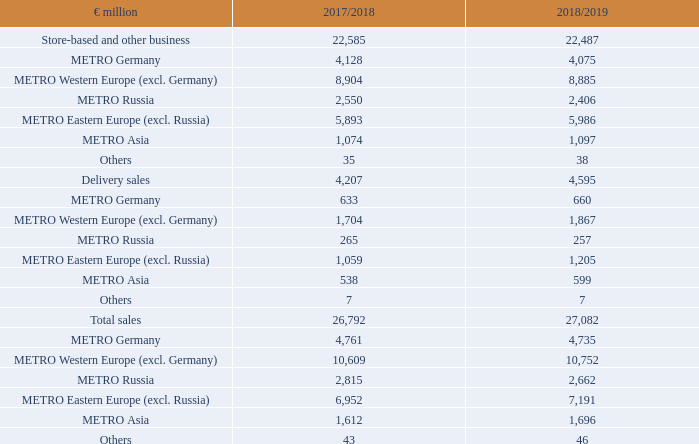1. Sales revenues
Commencing with financial year 2018/19, METRO has been applying IFRS 15 (Revenue from Contracts with Customers). The sales revenues reported for the current financial year relate exclusively to revenues from contracts with customers.
Sales revenues are allocated to the following categories:
When has METRO started applying IFRS 15? Commencing with financial year 2018/19. What do to the sales revenues reported for the current financial year relate to? Relate exclusively to revenues from contracts with customers. What are the categories of sales revenue allocations in the table? Store-based and other business, delivery sales, total sales. In which year was the Total sales larger? 27,082>26,792
Answer: 2018/2019. What was the change in Delivery sales in 2018/2019 from 2017/2018?
Answer scale should be: million. 4,595-4,207
Answer: 388. What was the percentage change in Delivery sales in 2018/2019 from 2017/2018?
Answer scale should be: percent. (4,595-4,207)/4,207
Answer: 9.22. 